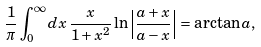<formula> <loc_0><loc_0><loc_500><loc_500>\frac { 1 } { \pi } \int _ { 0 } ^ { \infty } d x \, \frac { x } { 1 + x ^ { 2 } } \ln \left | \frac { a + x } { a - x } \right | = \arctan a ,</formula> 